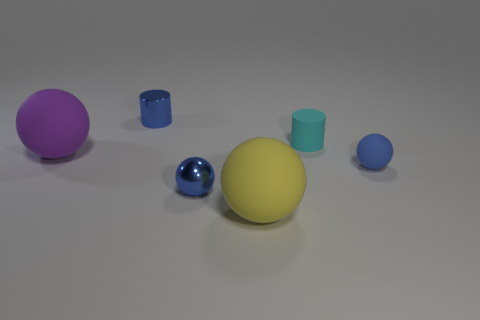There is another small ball that is the same color as the metal sphere; what is its material?
Provide a succinct answer. Rubber. There is a metal cylinder that is the same color as the small rubber ball; what size is it?
Your answer should be very brief. Small. Are there fewer tiny cyan objects that are on the left side of the purple object than objects on the right side of the small cyan cylinder?
Make the answer very short. Yes. Is the purple sphere made of the same material as the tiny blue ball that is left of the tiny cyan rubber object?
Ensure brevity in your answer.  No. Is there any other thing that is the same material as the cyan thing?
Give a very brief answer. Yes. Is the number of tiny metallic cylinders greater than the number of small blue spheres?
Your answer should be compact. No. What shape is the blue object on the right side of the small cylinder that is in front of the tiny metallic thing that is behind the small shiny ball?
Make the answer very short. Sphere. Is the blue ball that is right of the tiny cyan rubber object made of the same material as the large object to the left of the large yellow ball?
Make the answer very short. Yes. What is the shape of the purple thing that is made of the same material as the cyan object?
Give a very brief answer. Sphere. Is there anything else that has the same color as the shiny cylinder?
Your response must be concise. Yes. 